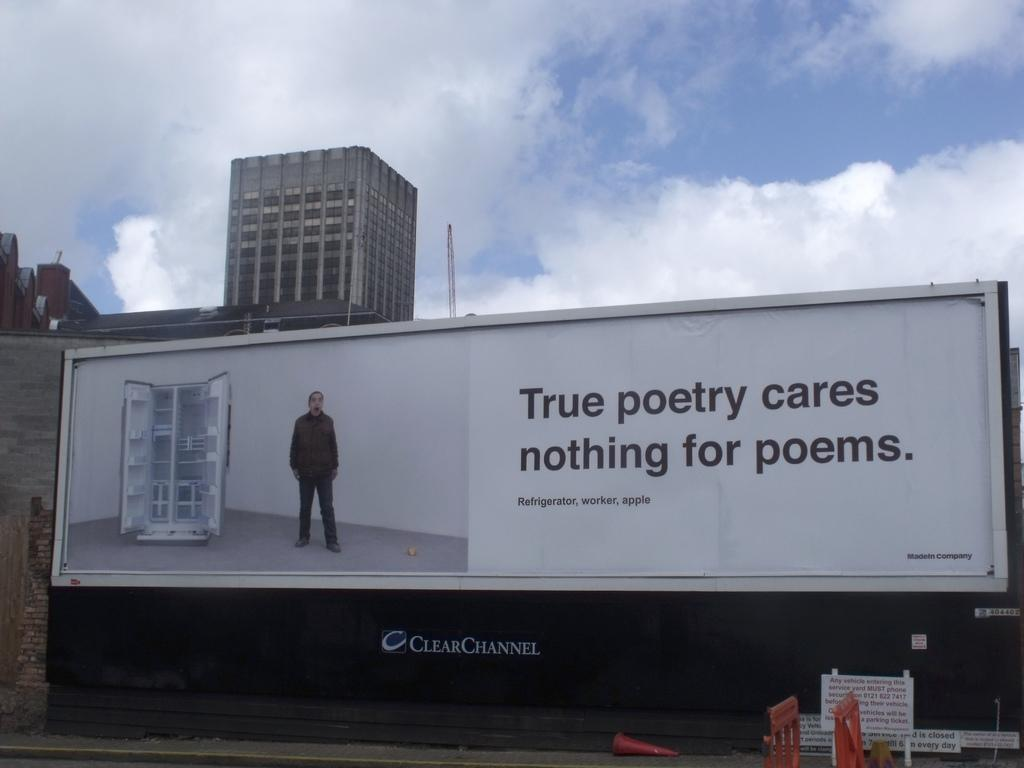<image>
Offer a succinct explanation of the picture presented. billboard that mentions True Poetry cares nothing for poems from Clear Channel. 